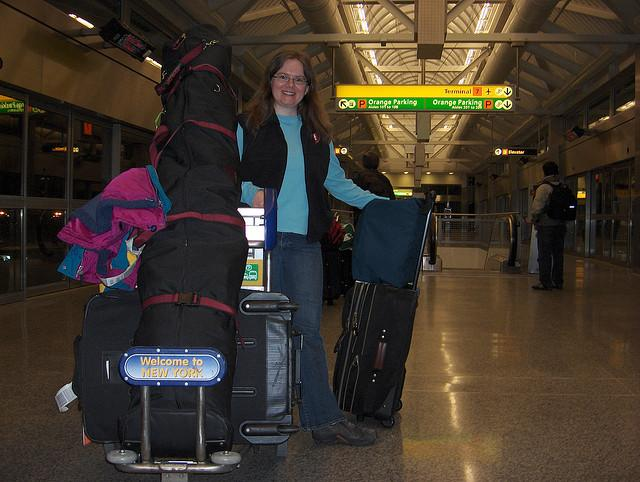What is the woman likely to use to get back home?

Choices:
A) car
B) airplane
C) taxi
D) covered wagon airplane 